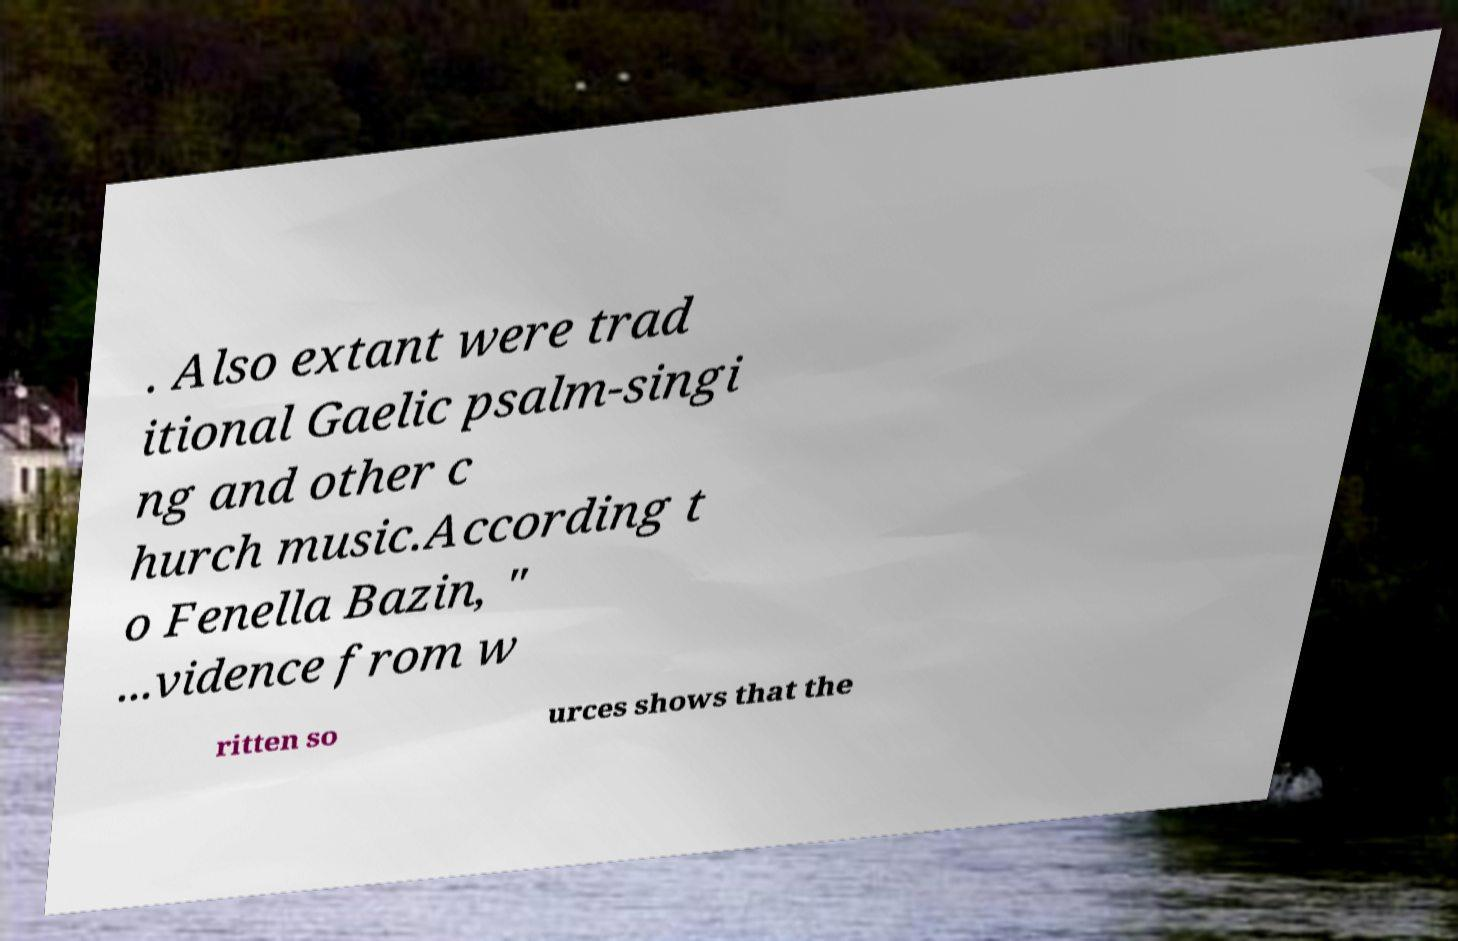There's text embedded in this image that I need extracted. Can you transcribe it verbatim? . Also extant were trad itional Gaelic psalm-singi ng and other c hurch music.According t o Fenella Bazin, " ...vidence from w ritten so urces shows that the 